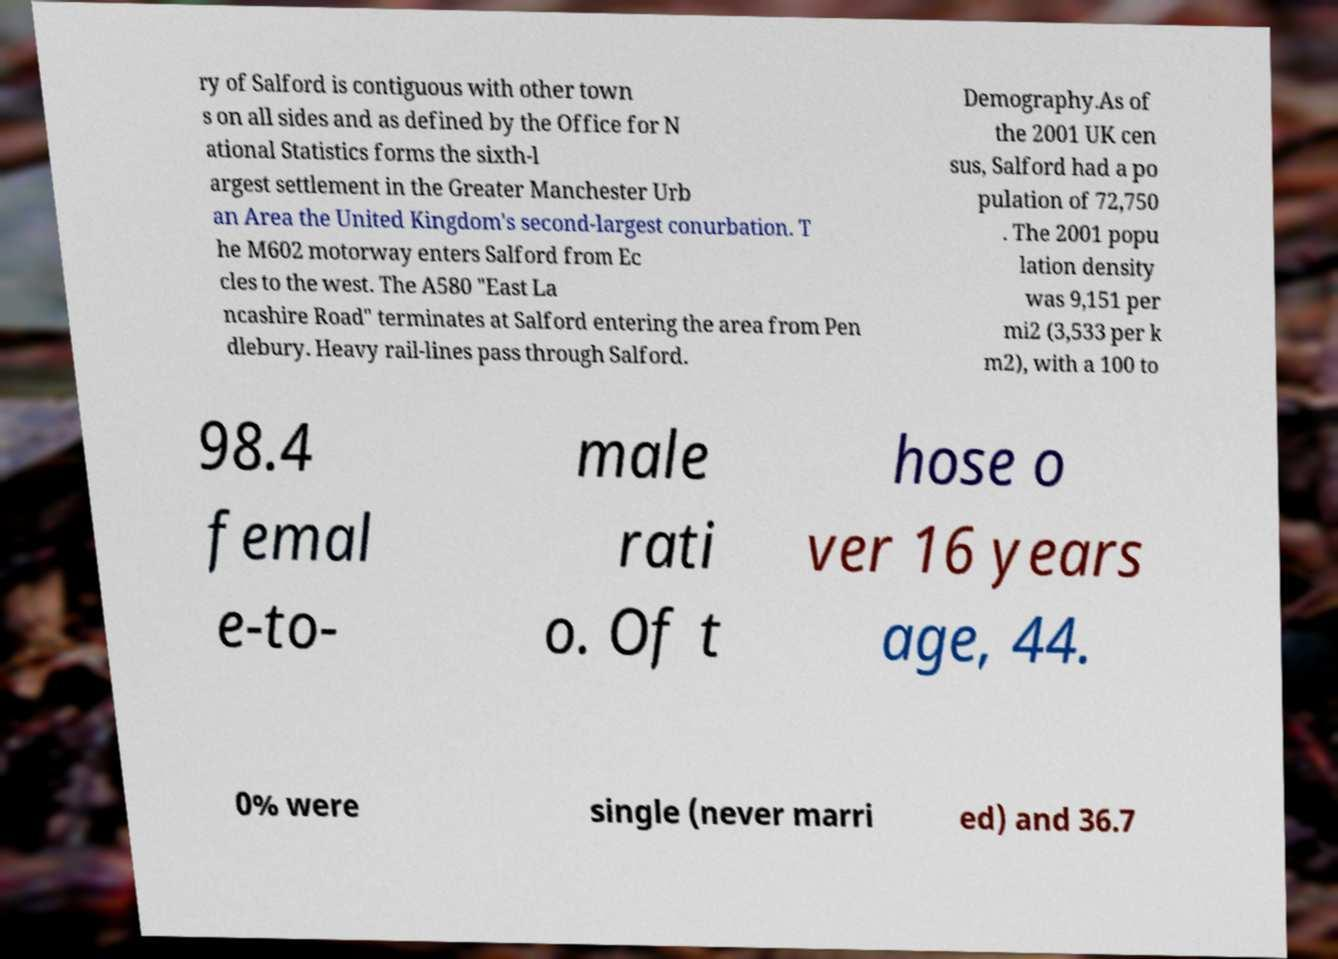Can you accurately transcribe the text from the provided image for me? ry of Salford is contiguous with other town s on all sides and as defined by the Office for N ational Statistics forms the sixth-l argest settlement in the Greater Manchester Urb an Area the United Kingdom's second-largest conurbation. T he M602 motorway enters Salford from Ec cles to the west. The A580 "East La ncashire Road" terminates at Salford entering the area from Pen dlebury. Heavy rail-lines pass through Salford. Demography.As of the 2001 UK cen sus, Salford had a po pulation of 72,750 . The 2001 popu lation density was 9,151 per mi2 (3,533 per k m2), with a 100 to 98.4 femal e-to- male rati o. Of t hose o ver 16 years age, 44. 0% were single (never marri ed) and 36.7 